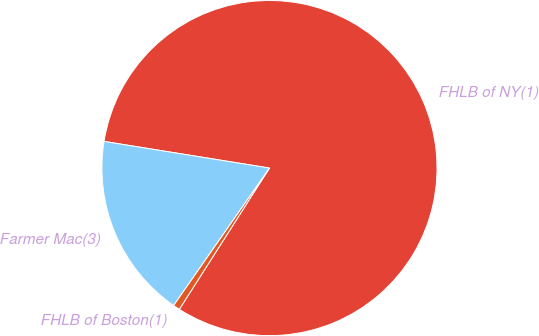Convert chart. <chart><loc_0><loc_0><loc_500><loc_500><pie_chart><fcel>FHLB of NY(1)<fcel>Farmer Mac(3)<fcel>FHLB of Boston(1)<nl><fcel>81.5%<fcel>17.85%<fcel>0.65%<nl></chart> 